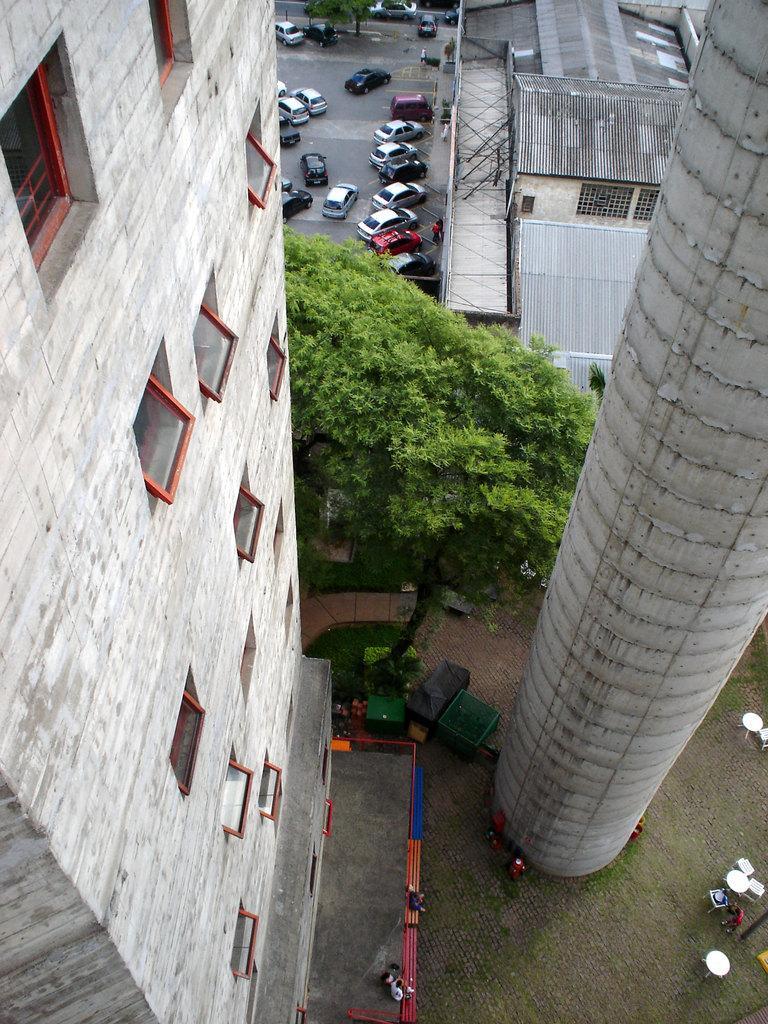Could you give a brief overview of what you see in this image? In this picture I can observe a building on the left side. On the right side there is a pillar. I can observe a tree in the middle of the picture. There are some cars parked on the road. 